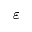Convert formula to latex. <formula><loc_0><loc_0><loc_500><loc_500>\varepsilon</formula> 